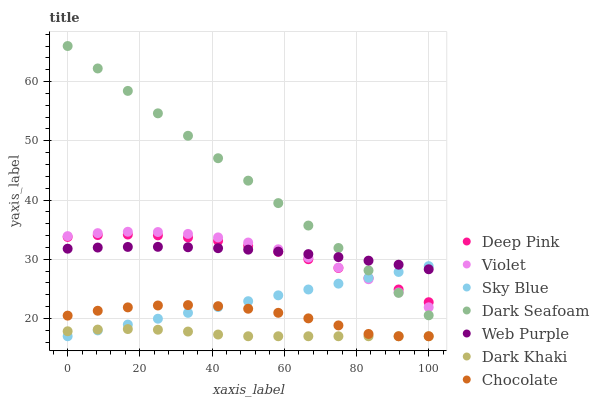Does Dark Khaki have the minimum area under the curve?
Answer yes or no. Yes. Does Dark Seafoam have the maximum area under the curve?
Answer yes or no. Yes. Does Web Purple have the minimum area under the curve?
Answer yes or no. No. Does Web Purple have the maximum area under the curve?
Answer yes or no. No. Is Sky Blue the smoothest?
Answer yes or no. Yes. Is Chocolate the roughest?
Answer yes or no. Yes. Is Web Purple the smoothest?
Answer yes or no. No. Is Web Purple the roughest?
Answer yes or no. No. Does Chocolate have the lowest value?
Answer yes or no. Yes. Does Web Purple have the lowest value?
Answer yes or no. No. Does Dark Seafoam have the highest value?
Answer yes or no. Yes. Does Web Purple have the highest value?
Answer yes or no. No. Is Chocolate less than Dark Seafoam?
Answer yes or no. Yes. Is Deep Pink greater than Dark Khaki?
Answer yes or no. Yes. Does Violet intersect Dark Seafoam?
Answer yes or no. Yes. Is Violet less than Dark Seafoam?
Answer yes or no. No. Is Violet greater than Dark Seafoam?
Answer yes or no. No. Does Chocolate intersect Dark Seafoam?
Answer yes or no. No. 